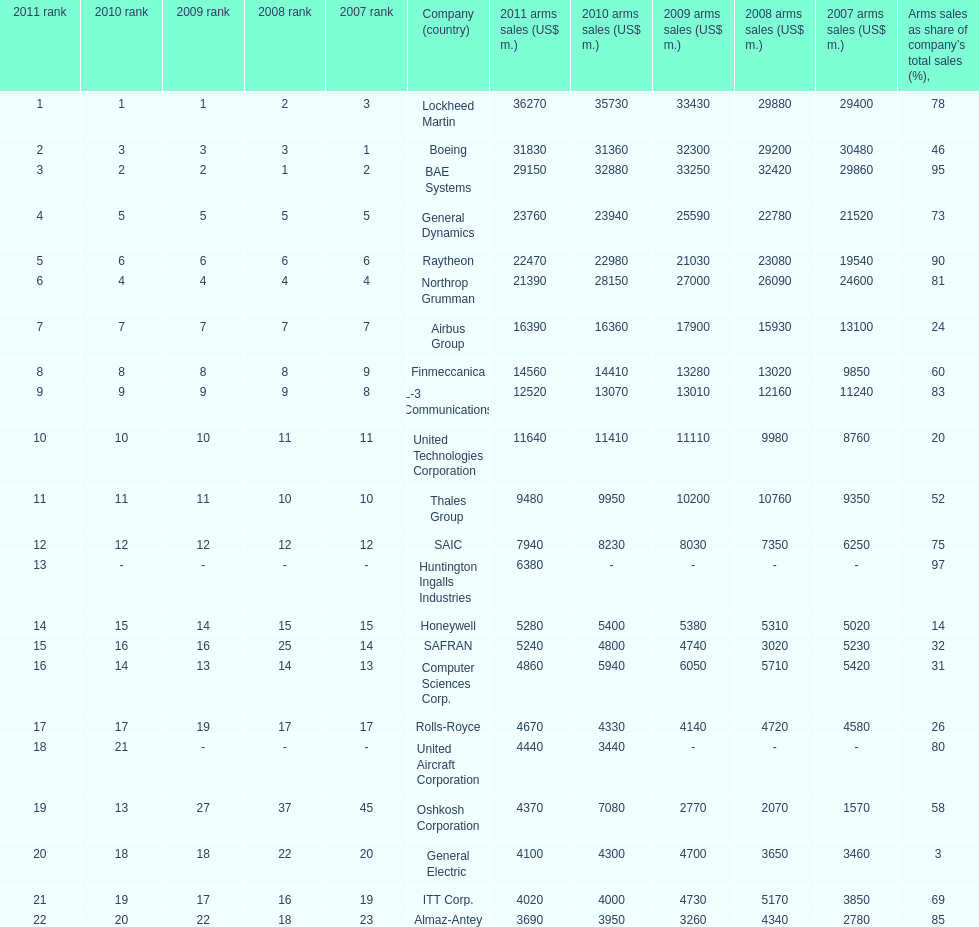Name all the companies whose arms sales as share of company's total sales is below 75%. Boeing, General Dynamics, Airbus Group, Finmeccanica, United Technologies Corporation, Thales Group, Honeywell, SAFRAN, Computer Sciences Corp., Rolls-Royce, Oshkosh Corporation, General Electric, ITT Corp. I'm looking to parse the entire table for insights. Could you assist me with that? {'header': ['2011 rank', '2010 rank', '2009 rank', '2008 rank', '2007 rank', 'Company (country)', '2011 arms sales (US$ m.)', '2010 arms sales (US$ m.)', '2009 arms sales (US$ m.)', '2008 arms sales (US$ m.)', '2007 arms sales (US$ m.)', 'Arms sales as share of company’s total sales (%),'], 'rows': [['1', '1', '1', '2', '3', 'Lockheed Martin', '36270', '35730', '33430', '29880', '29400', '78'], ['2', '3', '3', '3', '1', 'Boeing', '31830', '31360', '32300', '29200', '30480', '46'], ['3', '2', '2', '1', '2', 'BAE Systems', '29150', '32880', '33250', '32420', '29860', '95'], ['4', '5', '5', '5', '5', 'General Dynamics', '23760', '23940', '25590', '22780', '21520', '73'], ['5', '6', '6', '6', '6', 'Raytheon', '22470', '22980', '21030', '23080', '19540', '90'], ['6', '4', '4', '4', '4', 'Northrop Grumman', '21390', '28150', '27000', '26090', '24600', '81'], ['7', '7', '7', '7', '7', 'Airbus Group', '16390', '16360', '17900', '15930', '13100', '24'], ['8', '8', '8', '8', '9', 'Finmeccanica', '14560', '14410', '13280', '13020', '9850', '60'], ['9', '9', '9', '9', '8', 'L-3 Communications', '12520', '13070', '13010', '12160', '11240', '83'], ['10', '10', '10', '11', '11', 'United Technologies Corporation', '11640', '11410', '11110', '9980', '8760', '20'], ['11', '11', '11', '10', '10', 'Thales Group', '9480', '9950', '10200', '10760', '9350', '52'], ['12', '12', '12', '12', '12', 'SAIC', '7940', '8230', '8030', '7350', '6250', '75'], ['13', '-', '-', '-', '-', 'Huntington Ingalls Industries', '6380', '-', '-', '-', '-', '97'], ['14', '15', '14', '15', '15', 'Honeywell', '5280', '5400', '5380', '5310', '5020', '14'], ['15', '16', '16', '25', '14', 'SAFRAN', '5240', '4800', '4740', '3020', '5230', '32'], ['16', '14', '13', '14', '13', 'Computer Sciences Corp.', '4860', '5940', '6050', '5710', '5420', '31'], ['17', '17', '19', '17', '17', 'Rolls-Royce', '4670', '4330', '4140', '4720', '4580', '26'], ['18', '21', '-', '-', '-', 'United Aircraft Corporation', '4440', '3440', '-', '-', '-', '80'], ['19', '13', '27', '37', '45', 'Oshkosh Corporation', '4370', '7080', '2770', '2070', '1570', '58'], ['20', '18', '18', '22', '20', 'General Electric', '4100', '4300', '4700', '3650', '3460', '3'], ['21', '19', '17', '16', '19', 'ITT Corp.', '4020', '4000', '4730', '5170', '3850', '69'], ['22', '20', '22', '18', '23', 'Almaz-Antey', '3690', '3950', '3260', '4340', '2780', '85']]} 